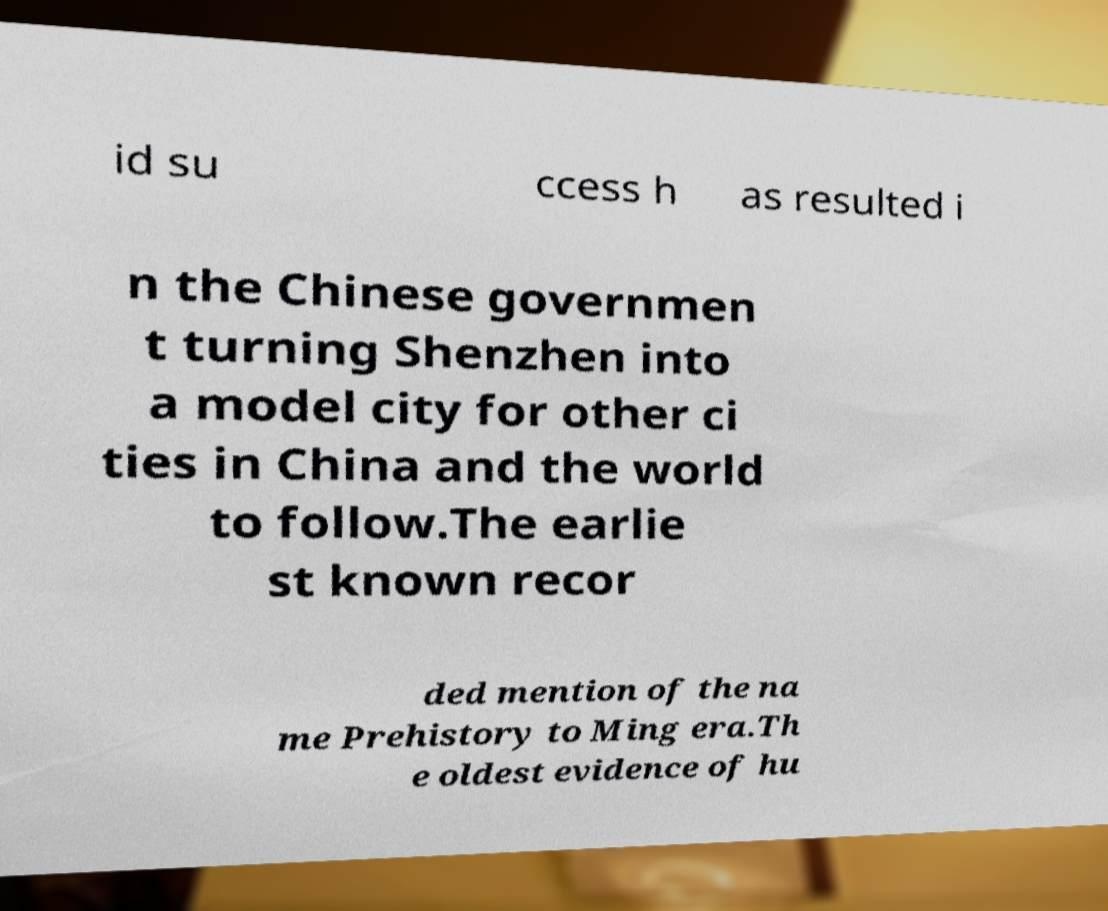Could you extract and type out the text from this image? id su ccess h as resulted i n the Chinese governmen t turning Shenzhen into a model city for other ci ties in China and the world to follow.The earlie st known recor ded mention of the na me Prehistory to Ming era.Th e oldest evidence of hu 